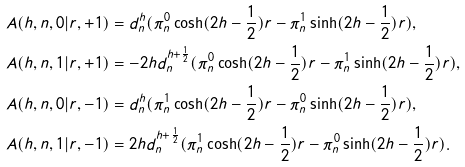Convert formula to latex. <formula><loc_0><loc_0><loc_500><loc_500>& A ( h , n , 0 | r , + 1 ) = d _ { n } ^ { h } ( \pi _ { n } ^ { 0 } \cosh ( 2 h - \frac { 1 } { 2 } ) r - \pi _ { n } ^ { 1 } \sinh ( 2 h - \frac { 1 } { 2 } ) r ) , \\ & A ( h , n , 1 | r , + 1 ) = - 2 h d _ { n } ^ { h + \frac { 1 } { 2 } } ( \pi _ { n } ^ { 0 } \cosh ( 2 h - \frac { 1 } { 2 } ) r - \pi _ { n } ^ { 1 } \sinh ( 2 h - \frac { 1 } { 2 } ) r ) , \\ & A ( h , n , 0 | r , - 1 ) = d _ { n } ^ { h } ( \pi _ { n } ^ { 1 } \cosh ( 2 h - \frac { 1 } { 2 } ) r - \pi _ { n } ^ { 0 } \sinh ( 2 h - \frac { 1 } { 2 } ) r ) , \\ & A ( h , n , 1 | r , - 1 ) = 2 h d _ { n } ^ { h + \frac { 1 } { 2 } } ( \pi _ { n } ^ { 1 } \cosh ( 2 h - \frac { 1 } { 2 } ) r - \pi _ { n } ^ { 0 } \sinh ( 2 h - \frac { 1 } { 2 } ) r ) .</formula> 